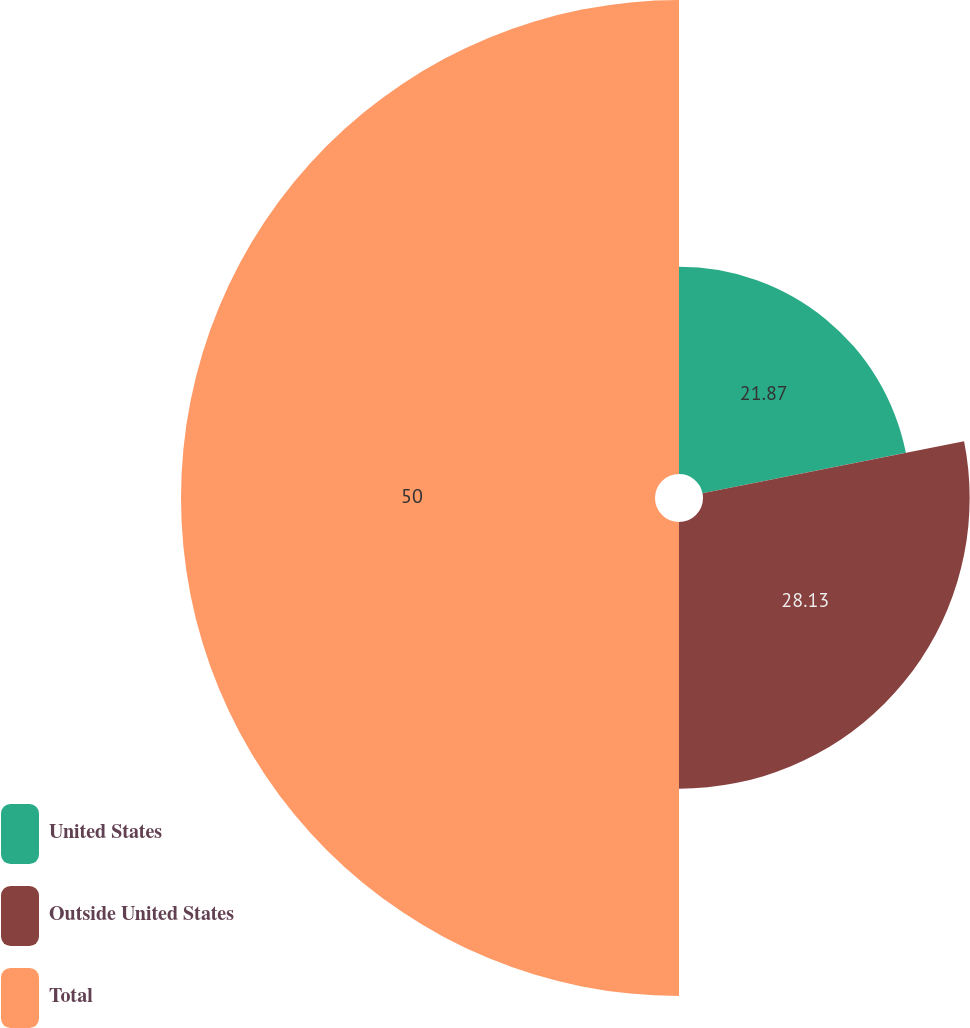Convert chart. <chart><loc_0><loc_0><loc_500><loc_500><pie_chart><fcel>United States<fcel>Outside United States<fcel>Total<nl><fcel>21.87%<fcel>28.13%<fcel>50.0%<nl></chart> 